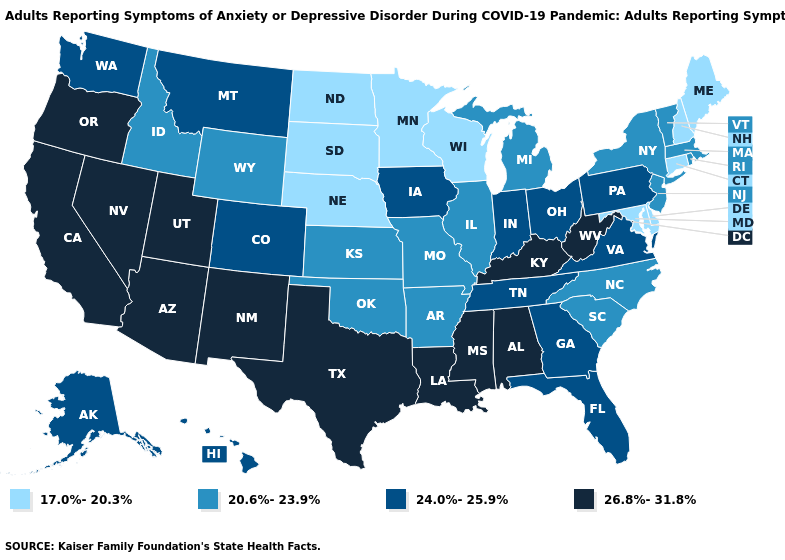Does Virginia have a lower value than Georgia?
Quick response, please. No. What is the value of Alaska?
Answer briefly. 24.0%-25.9%. Which states have the highest value in the USA?
Be succinct. Alabama, Arizona, California, Kentucky, Louisiana, Mississippi, Nevada, New Mexico, Oregon, Texas, Utah, West Virginia. Does Kentucky have a higher value than Indiana?
Be succinct. Yes. What is the value of Wyoming?
Concise answer only. 20.6%-23.9%. Name the states that have a value in the range 26.8%-31.8%?
Concise answer only. Alabama, Arizona, California, Kentucky, Louisiana, Mississippi, Nevada, New Mexico, Oregon, Texas, Utah, West Virginia. What is the value of Colorado?
Write a very short answer. 24.0%-25.9%. Among the states that border Kansas , does Colorado have the highest value?
Answer briefly. Yes. What is the lowest value in the USA?
Quick response, please. 17.0%-20.3%. Does Texas have the highest value in the South?
Give a very brief answer. Yes. What is the value of Maine?
Short answer required. 17.0%-20.3%. Among the states that border Georgia , does South Carolina have the highest value?
Be succinct. No. Name the states that have a value in the range 20.6%-23.9%?
Keep it brief. Arkansas, Idaho, Illinois, Kansas, Massachusetts, Michigan, Missouri, New Jersey, New York, North Carolina, Oklahoma, Rhode Island, South Carolina, Vermont, Wyoming. Name the states that have a value in the range 24.0%-25.9%?
Give a very brief answer. Alaska, Colorado, Florida, Georgia, Hawaii, Indiana, Iowa, Montana, Ohio, Pennsylvania, Tennessee, Virginia, Washington. What is the lowest value in states that border Arizona?
Be succinct. 24.0%-25.9%. 